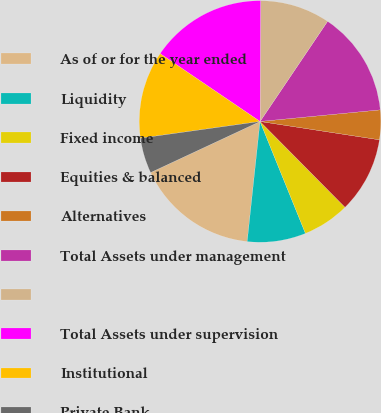Convert chart to OTSL. <chart><loc_0><loc_0><loc_500><loc_500><pie_chart><fcel>As of or for the year ended<fcel>Liquidity<fcel>Fixed income<fcel>Equities & balanced<fcel>Alternatives<fcel>Total Assets under management<fcel>Unnamed: 6<fcel>Total Assets under supervision<fcel>Institutional<fcel>Private Bank<nl><fcel>16.35%<fcel>7.83%<fcel>6.29%<fcel>10.15%<fcel>3.96%<fcel>14.02%<fcel>9.38%<fcel>15.57%<fcel>11.7%<fcel>4.74%<nl></chart> 